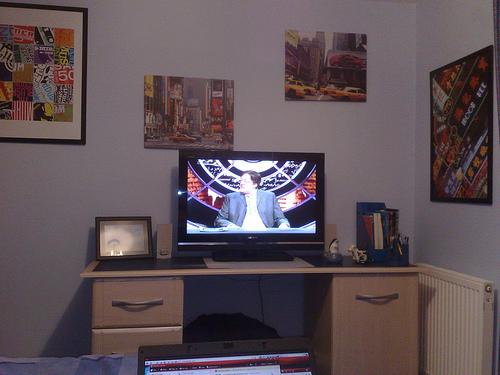Pose a question that inquires about the material of a specific object and supply the appropriate answer. The handle on the drawer is made of metal. Write a question related to the appearance of the desk and provide the accurate answer to it. The wooden desk is light brown. Tell a story about a person on the TV in the image. There once was a man talking passionately in front of a unique curved design, capturing the attention of many viewers as his face appeared on the television. Choose 3 objects in the image and write a sentence using adjectives that describe each. The cozy bed has a blue cover, the small wooden desk is light-colored, and the radiator situated against the wall is white. Provide a detailed description of a specific object in the image. The television on the desk features a man talking in front of a curved design, with its screen glowing brightly and attracting the viewer's attention. Describe the activities that might transpire in this room. This room serves as a comfortable and functional space where someone can work on the laptop, watch TV, engage in hobbies, or simply relax in bed with their favorite book. Express the setting depicted in the image using simple vocabulary and structure. A room with a desk, laptop, TV, pictures, and toys. Ask an open-ended question about the image and respond with a likely explanation. The person living in this room might be an art enthusiast or wants to add a personal touch to their space by displaying diverse imagery. Create a concise narrative using at least five key objects from the image. In the corner of the room, the small wooden desk hosts a television with a man talking, a laptop for work, framed pictures and certificates that inspire, and a blue-covered bed inviting a well-deserved rest after a busy day. Imagine the items on the desk belonged to a student, then craft a short narrative describing their purpose. The diligent student would sit at their light-colored wooden desk every day, surrounded by their figurines and books, utilizing the television for educational programming and the laptop for study and research purposes. 